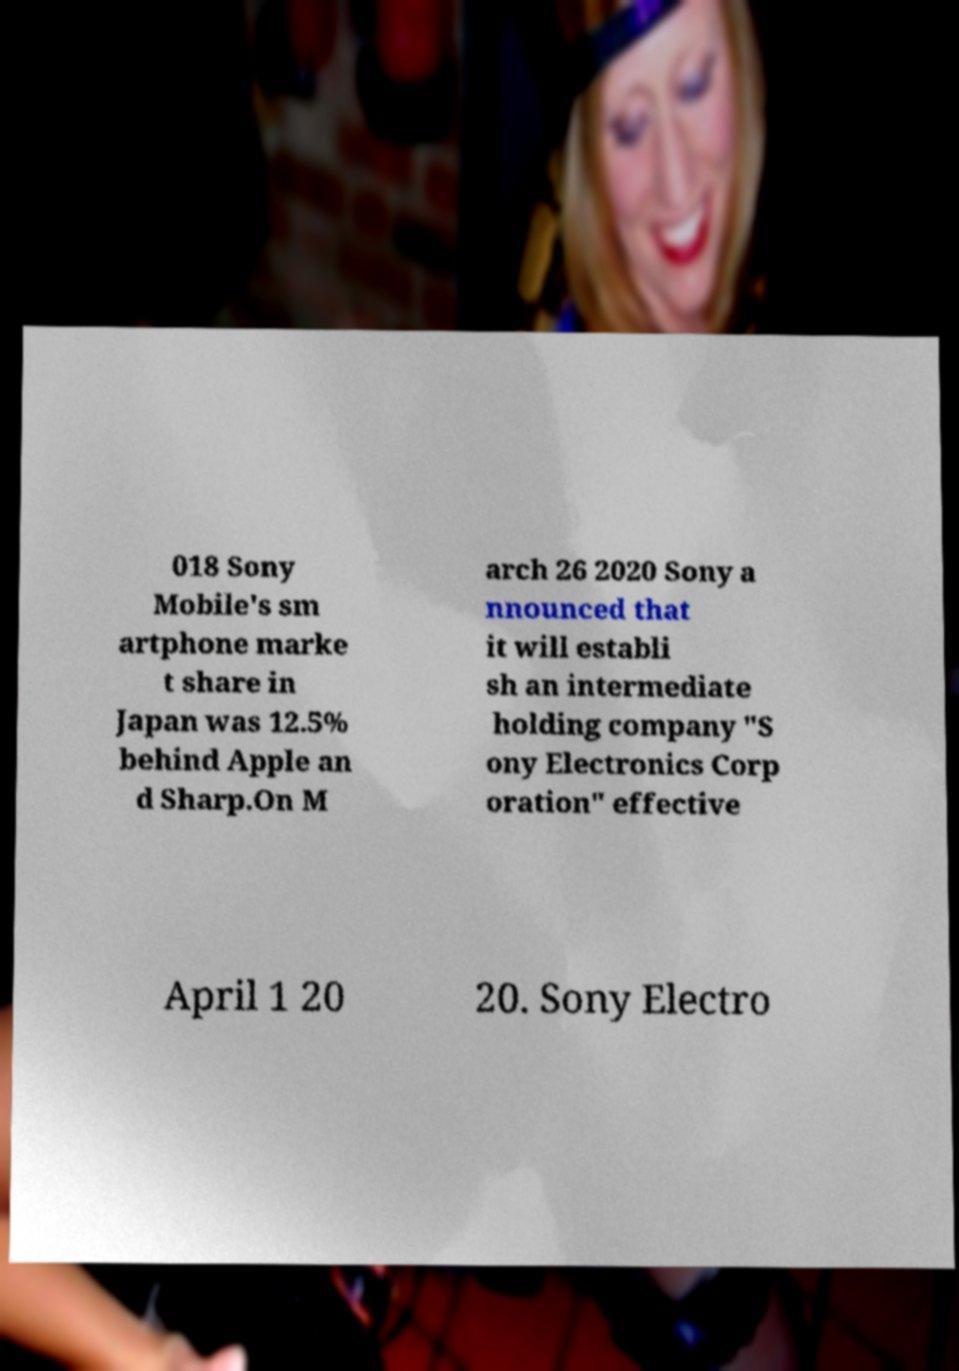Could you extract and type out the text from this image? 018 Sony Mobile's sm artphone marke t share in Japan was 12.5% behind Apple an d Sharp.On M arch 26 2020 Sony a nnounced that it will establi sh an intermediate holding company "S ony Electronics Corp oration" effective April 1 20 20. Sony Electro 